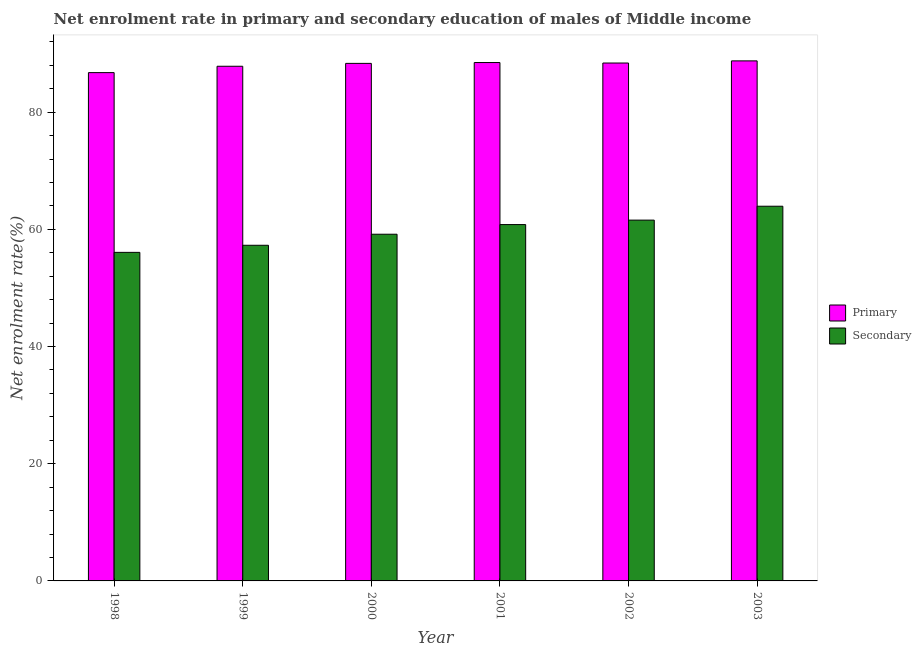How many different coloured bars are there?
Your answer should be compact. 2. How many groups of bars are there?
Offer a very short reply. 6. Are the number of bars on each tick of the X-axis equal?
Your response must be concise. Yes. How many bars are there on the 5th tick from the left?
Provide a short and direct response. 2. What is the label of the 2nd group of bars from the left?
Provide a short and direct response. 1999. What is the enrollment rate in primary education in 2000?
Provide a short and direct response. 88.33. Across all years, what is the maximum enrollment rate in secondary education?
Your answer should be very brief. 63.95. Across all years, what is the minimum enrollment rate in secondary education?
Offer a terse response. 56.07. In which year was the enrollment rate in secondary education maximum?
Your answer should be compact. 2003. In which year was the enrollment rate in primary education minimum?
Give a very brief answer. 1998. What is the total enrollment rate in secondary education in the graph?
Ensure brevity in your answer.  358.88. What is the difference between the enrollment rate in primary education in 2001 and that in 2003?
Make the answer very short. -0.28. What is the difference between the enrollment rate in primary education in 2001 and the enrollment rate in secondary education in 1998?
Provide a succinct answer. 1.72. What is the average enrollment rate in primary education per year?
Your answer should be very brief. 88.09. In the year 2001, what is the difference between the enrollment rate in secondary education and enrollment rate in primary education?
Your response must be concise. 0. What is the ratio of the enrollment rate in secondary education in 1999 to that in 2001?
Offer a very short reply. 0.94. Is the enrollment rate in primary education in 2002 less than that in 2003?
Ensure brevity in your answer.  Yes. What is the difference between the highest and the second highest enrollment rate in primary education?
Your answer should be very brief. 0.28. What is the difference between the highest and the lowest enrollment rate in secondary education?
Offer a very short reply. 7.87. Is the sum of the enrollment rate in secondary education in 2000 and 2001 greater than the maximum enrollment rate in primary education across all years?
Keep it short and to the point. Yes. What does the 1st bar from the left in 2001 represents?
Your response must be concise. Primary. What does the 1st bar from the right in 2000 represents?
Your answer should be very brief. Secondary. How many years are there in the graph?
Keep it short and to the point. 6. What is the difference between two consecutive major ticks on the Y-axis?
Keep it short and to the point. 20. Does the graph contain grids?
Offer a terse response. No. Where does the legend appear in the graph?
Make the answer very short. Center right. How many legend labels are there?
Your answer should be compact. 2. How are the legend labels stacked?
Give a very brief answer. Vertical. What is the title of the graph?
Your answer should be very brief. Net enrolment rate in primary and secondary education of males of Middle income. Does "Fixed telephone" appear as one of the legend labels in the graph?
Your answer should be compact. No. What is the label or title of the X-axis?
Give a very brief answer. Year. What is the label or title of the Y-axis?
Keep it short and to the point. Net enrolment rate(%). What is the Net enrolment rate(%) in Primary in 1998?
Your answer should be very brief. 86.75. What is the Net enrolment rate(%) in Secondary in 1998?
Keep it short and to the point. 56.07. What is the Net enrolment rate(%) in Primary in 1999?
Offer a terse response. 87.84. What is the Net enrolment rate(%) of Secondary in 1999?
Your answer should be very brief. 57.28. What is the Net enrolment rate(%) in Primary in 2000?
Your answer should be compact. 88.33. What is the Net enrolment rate(%) in Secondary in 2000?
Offer a terse response. 59.17. What is the Net enrolment rate(%) of Primary in 2001?
Provide a succinct answer. 88.47. What is the Net enrolment rate(%) of Secondary in 2001?
Your response must be concise. 60.82. What is the Net enrolment rate(%) in Primary in 2002?
Provide a short and direct response. 88.39. What is the Net enrolment rate(%) of Secondary in 2002?
Your response must be concise. 61.58. What is the Net enrolment rate(%) of Primary in 2003?
Provide a short and direct response. 88.76. What is the Net enrolment rate(%) of Secondary in 2003?
Provide a short and direct response. 63.95. Across all years, what is the maximum Net enrolment rate(%) of Primary?
Your answer should be compact. 88.76. Across all years, what is the maximum Net enrolment rate(%) of Secondary?
Your answer should be compact. 63.95. Across all years, what is the minimum Net enrolment rate(%) in Primary?
Provide a succinct answer. 86.75. Across all years, what is the minimum Net enrolment rate(%) in Secondary?
Keep it short and to the point. 56.07. What is the total Net enrolment rate(%) of Primary in the graph?
Offer a very short reply. 528.54. What is the total Net enrolment rate(%) of Secondary in the graph?
Your response must be concise. 358.88. What is the difference between the Net enrolment rate(%) of Primary in 1998 and that in 1999?
Provide a short and direct response. -1.08. What is the difference between the Net enrolment rate(%) of Secondary in 1998 and that in 1999?
Your answer should be compact. -1.21. What is the difference between the Net enrolment rate(%) in Primary in 1998 and that in 2000?
Keep it short and to the point. -1.58. What is the difference between the Net enrolment rate(%) in Secondary in 1998 and that in 2000?
Your response must be concise. -3.1. What is the difference between the Net enrolment rate(%) of Primary in 1998 and that in 2001?
Provide a short and direct response. -1.72. What is the difference between the Net enrolment rate(%) in Secondary in 1998 and that in 2001?
Make the answer very short. -4.74. What is the difference between the Net enrolment rate(%) in Primary in 1998 and that in 2002?
Give a very brief answer. -1.64. What is the difference between the Net enrolment rate(%) in Secondary in 1998 and that in 2002?
Make the answer very short. -5.5. What is the difference between the Net enrolment rate(%) in Primary in 1998 and that in 2003?
Make the answer very short. -2. What is the difference between the Net enrolment rate(%) in Secondary in 1998 and that in 2003?
Offer a very short reply. -7.87. What is the difference between the Net enrolment rate(%) of Primary in 1999 and that in 2000?
Make the answer very short. -0.49. What is the difference between the Net enrolment rate(%) in Secondary in 1999 and that in 2000?
Provide a succinct answer. -1.89. What is the difference between the Net enrolment rate(%) in Primary in 1999 and that in 2001?
Offer a very short reply. -0.63. What is the difference between the Net enrolment rate(%) in Secondary in 1999 and that in 2001?
Your response must be concise. -3.53. What is the difference between the Net enrolment rate(%) of Primary in 1999 and that in 2002?
Your answer should be very brief. -0.55. What is the difference between the Net enrolment rate(%) of Secondary in 1999 and that in 2002?
Offer a very short reply. -4.29. What is the difference between the Net enrolment rate(%) in Primary in 1999 and that in 2003?
Give a very brief answer. -0.92. What is the difference between the Net enrolment rate(%) in Secondary in 1999 and that in 2003?
Offer a very short reply. -6.66. What is the difference between the Net enrolment rate(%) of Primary in 2000 and that in 2001?
Make the answer very short. -0.14. What is the difference between the Net enrolment rate(%) of Secondary in 2000 and that in 2001?
Make the answer very short. -1.65. What is the difference between the Net enrolment rate(%) in Primary in 2000 and that in 2002?
Your answer should be very brief. -0.06. What is the difference between the Net enrolment rate(%) in Secondary in 2000 and that in 2002?
Keep it short and to the point. -2.41. What is the difference between the Net enrolment rate(%) of Primary in 2000 and that in 2003?
Offer a terse response. -0.43. What is the difference between the Net enrolment rate(%) in Secondary in 2000 and that in 2003?
Ensure brevity in your answer.  -4.78. What is the difference between the Net enrolment rate(%) in Primary in 2001 and that in 2002?
Offer a terse response. 0.08. What is the difference between the Net enrolment rate(%) of Secondary in 2001 and that in 2002?
Give a very brief answer. -0.76. What is the difference between the Net enrolment rate(%) in Primary in 2001 and that in 2003?
Provide a succinct answer. -0.28. What is the difference between the Net enrolment rate(%) of Secondary in 2001 and that in 2003?
Your response must be concise. -3.13. What is the difference between the Net enrolment rate(%) of Primary in 2002 and that in 2003?
Keep it short and to the point. -0.37. What is the difference between the Net enrolment rate(%) of Secondary in 2002 and that in 2003?
Ensure brevity in your answer.  -2.37. What is the difference between the Net enrolment rate(%) of Primary in 1998 and the Net enrolment rate(%) of Secondary in 1999?
Give a very brief answer. 29.47. What is the difference between the Net enrolment rate(%) of Primary in 1998 and the Net enrolment rate(%) of Secondary in 2000?
Your answer should be compact. 27.58. What is the difference between the Net enrolment rate(%) in Primary in 1998 and the Net enrolment rate(%) in Secondary in 2001?
Ensure brevity in your answer.  25.94. What is the difference between the Net enrolment rate(%) in Primary in 1998 and the Net enrolment rate(%) in Secondary in 2002?
Your answer should be compact. 25.17. What is the difference between the Net enrolment rate(%) in Primary in 1998 and the Net enrolment rate(%) in Secondary in 2003?
Ensure brevity in your answer.  22.8. What is the difference between the Net enrolment rate(%) in Primary in 1999 and the Net enrolment rate(%) in Secondary in 2000?
Keep it short and to the point. 28.67. What is the difference between the Net enrolment rate(%) of Primary in 1999 and the Net enrolment rate(%) of Secondary in 2001?
Provide a short and direct response. 27.02. What is the difference between the Net enrolment rate(%) of Primary in 1999 and the Net enrolment rate(%) of Secondary in 2002?
Give a very brief answer. 26.26. What is the difference between the Net enrolment rate(%) of Primary in 1999 and the Net enrolment rate(%) of Secondary in 2003?
Give a very brief answer. 23.89. What is the difference between the Net enrolment rate(%) of Primary in 2000 and the Net enrolment rate(%) of Secondary in 2001?
Provide a succinct answer. 27.51. What is the difference between the Net enrolment rate(%) in Primary in 2000 and the Net enrolment rate(%) in Secondary in 2002?
Provide a short and direct response. 26.75. What is the difference between the Net enrolment rate(%) in Primary in 2000 and the Net enrolment rate(%) in Secondary in 2003?
Provide a succinct answer. 24.38. What is the difference between the Net enrolment rate(%) in Primary in 2001 and the Net enrolment rate(%) in Secondary in 2002?
Your answer should be very brief. 26.89. What is the difference between the Net enrolment rate(%) of Primary in 2001 and the Net enrolment rate(%) of Secondary in 2003?
Keep it short and to the point. 24.52. What is the difference between the Net enrolment rate(%) in Primary in 2002 and the Net enrolment rate(%) in Secondary in 2003?
Your response must be concise. 24.44. What is the average Net enrolment rate(%) of Primary per year?
Provide a succinct answer. 88.09. What is the average Net enrolment rate(%) in Secondary per year?
Keep it short and to the point. 59.81. In the year 1998, what is the difference between the Net enrolment rate(%) in Primary and Net enrolment rate(%) in Secondary?
Your response must be concise. 30.68. In the year 1999, what is the difference between the Net enrolment rate(%) of Primary and Net enrolment rate(%) of Secondary?
Make the answer very short. 30.55. In the year 2000, what is the difference between the Net enrolment rate(%) of Primary and Net enrolment rate(%) of Secondary?
Offer a terse response. 29.16. In the year 2001, what is the difference between the Net enrolment rate(%) of Primary and Net enrolment rate(%) of Secondary?
Offer a very short reply. 27.65. In the year 2002, what is the difference between the Net enrolment rate(%) in Primary and Net enrolment rate(%) in Secondary?
Make the answer very short. 26.81. In the year 2003, what is the difference between the Net enrolment rate(%) of Primary and Net enrolment rate(%) of Secondary?
Your answer should be compact. 24.81. What is the ratio of the Net enrolment rate(%) of Secondary in 1998 to that in 1999?
Keep it short and to the point. 0.98. What is the ratio of the Net enrolment rate(%) in Primary in 1998 to that in 2000?
Offer a very short reply. 0.98. What is the ratio of the Net enrolment rate(%) in Secondary in 1998 to that in 2000?
Your answer should be very brief. 0.95. What is the ratio of the Net enrolment rate(%) in Primary in 1998 to that in 2001?
Give a very brief answer. 0.98. What is the ratio of the Net enrolment rate(%) of Secondary in 1998 to that in 2001?
Keep it short and to the point. 0.92. What is the ratio of the Net enrolment rate(%) in Primary in 1998 to that in 2002?
Give a very brief answer. 0.98. What is the ratio of the Net enrolment rate(%) of Secondary in 1998 to that in 2002?
Your answer should be very brief. 0.91. What is the ratio of the Net enrolment rate(%) in Primary in 1998 to that in 2003?
Offer a very short reply. 0.98. What is the ratio of the Net enrolment rate(%) in Secondary in 1998 to that in 2003?
Provide a succinct answer. 0.88. What is the ratio of the Net enrolment rate(%) in Primary in 1999 to that in 2000?
Provide a short and direct response. 0.99. What is the ratio of the Net enrolment rate(%) in Secondary in 1999 to that in 2000?
Offer a terse response. 0.97. What is the ratio of the Net enrolment rate(%) in Secondary in 1999 to that in 2001?
Provide a succinct answer. 0.94. What is the ratio of the Net enrolment rate(%) of Primary in 1999 to that in 2002?
Your answer should be compact. 0.99. What is the ratio of the Net enrolment rate(%) of Secondary in 1999 to that in 2002?
Your answer should be compact. 0.93. What is the ratio of the Net enrolment rate(%) of Primary in 1999 to that in 2003?
Offer a terse response. 0.99. What is the ratio of the Net enrolment rate(%) of Secondary in 1999 to that in 2003?
Provide a short and direct response. 0.9. What is the ratio of the Net enrolment rate(%) in Secondary in 2000 to that in 2001?
Keep it short and to the point. 0.97. What is the ratio of the Net enrolment rate(%) of Secondary in 2000 to that in 2002?
Your response must be concise. 0.96. What is the ratio of the Net enrolment rate(%) of Secondary in 2000 to that in 2003?
Give a very brief answer. 0.93. What is the ratio of the Net enrolment rate(%) in Secondary in 2001 to that in 2002?
Your answer should be compact. 0.99. What is the ratio of the Net enrolment rate(%) of Secondary in 2001 to that in 2003?
Make the answer very short. 0.95. What is the ratio of the Net enrolment rate(%) of Secondary in 2002 to that in 2003?
Provide a succinct answer. 0.96. What is the difference between the highest and the second highest Net enrolment rate(%) in Primary?
Your response must be concise. 0.28. What is the difference between the highest and the second highest Net enrolment rate(%) of Secondary?
Your response must be concise. 2.37. What is the difference between the highest and the lowest Net enrolment rate(%) in Primary?
Keep it short and to the point. 2. What is the difference between the highest and the lowest Net enrolment rate(%) of Secondary?
Give a very brief answer. 7.87. 